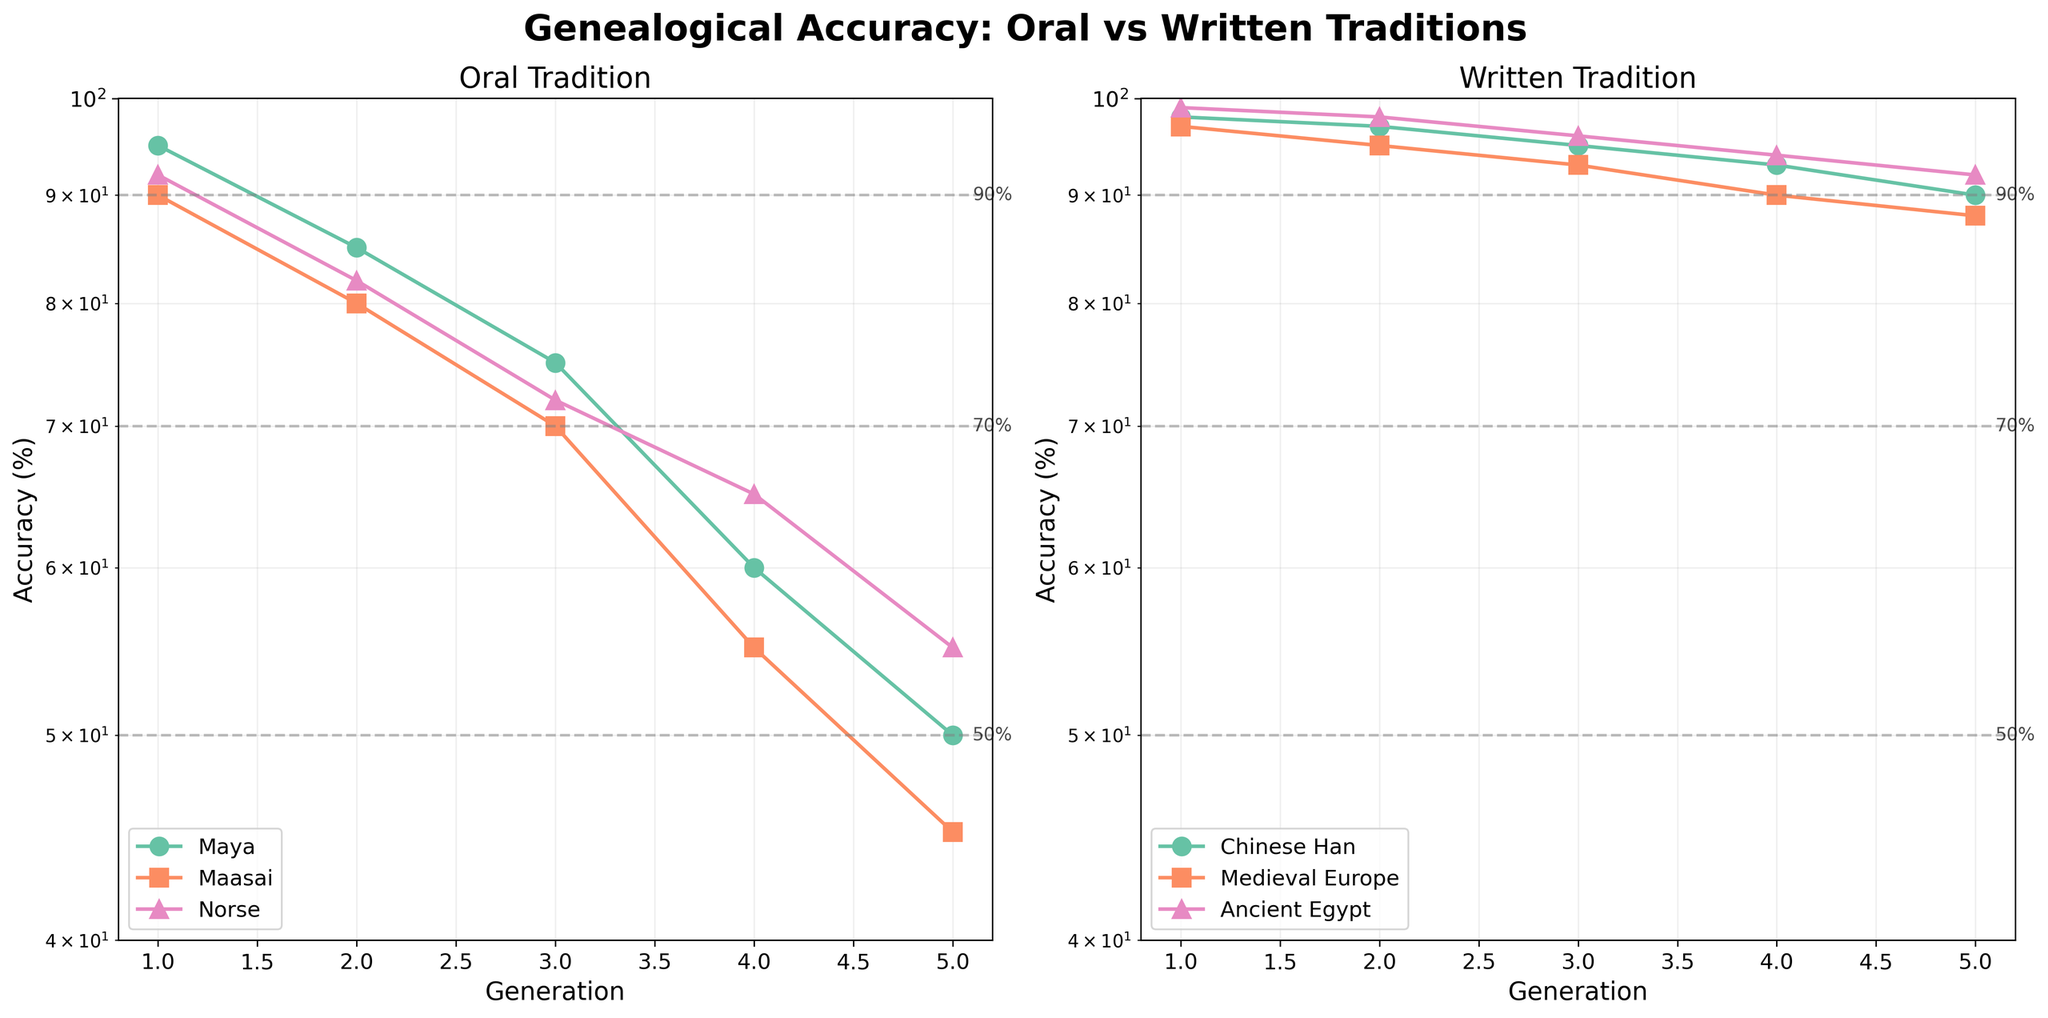What is the title of the figure? The title is displayed at the top center of the figure and reads "Genealogical Accuracy: Oral vs Written Traditions" in bold font.
Answer: Genealogical Accuracy: Oral vs Written Traditions What is the accuracy of Norse oral tradition in the 2nd generation? Locate the Norse data points under the 'Oral' subplot. Find the point corresponding to the 2nd generation, which shows an accuracy of 82%.
Answer: 82% Which tradition, oral or written, maintains a higher accuracy in the 5th generation for the entities analyzed? Compare the accuracy values in the 5th generation for both subplots. The highest value for oral traditions is 55 (Norse) while for written traditions it is 92 (Ancient Egypt).
Answer: Written How does the accuracy of the Chinese Han written tradition compare between the 1st and 5th generations? Examine the data points for Chinese Han in the written tradition subplot. The accuracy decreases from 98% in the 1st generation to 90% in the 5th generation.
Answer: Decreases from 98% to 90% What percentage of accuracy is achieved by Maasai oral tradition in the 4th generation? Locate the Maasai data points under the 'Oral' subplot. Find the point corresponding to the 4th generation, which shows an accuracy of 55%.
Answer: 55% What is the difference in genealogical accuracy between the Maya oral tradition and the Ancient Egypt written tradition in the 3rd generation? Locate the data points for each in the 3rd generation. Maya has 75% in the oral subplot, and Ancient Egypt has 96% in the written subplot. The difference is 96 - 75 = 21%.
Answer: 21% Is the trend of genealogical accuracy decreasing more rapidly in oral traditions compared to written traditions? Observe the slopes of the lines in both subplots. The lines in the oral subplot typically show steeper declines compared to the more gradual declines in the written subplot.
Answer: Yes By which generation does any oral tradition first drop below 50% accuracy? Check each entity's line in the oral subplot for the first occurrence below the 50% horizontal line. The Maasai tradition drops below 50% in the 5th generation.
Answer: 5th generation What is the accuracy of Medieval Europe written tradition in the 4th generation, and what does this suggest about the reliability of written records over time? Locate the Medieval Europe points under the 'Written' subplot. In the 4th generation, the accuracy is 90%. This suggests that written records maintain higher reliability over time.
Answer: 90% Do any oral traditions maintain an accuracy above 90% after the 1st generation? Check the oral tradition subplot for values above the 90% horizontal line after the 1st generation. No data points exceed 90% after the 1st generation.
Answer: No 